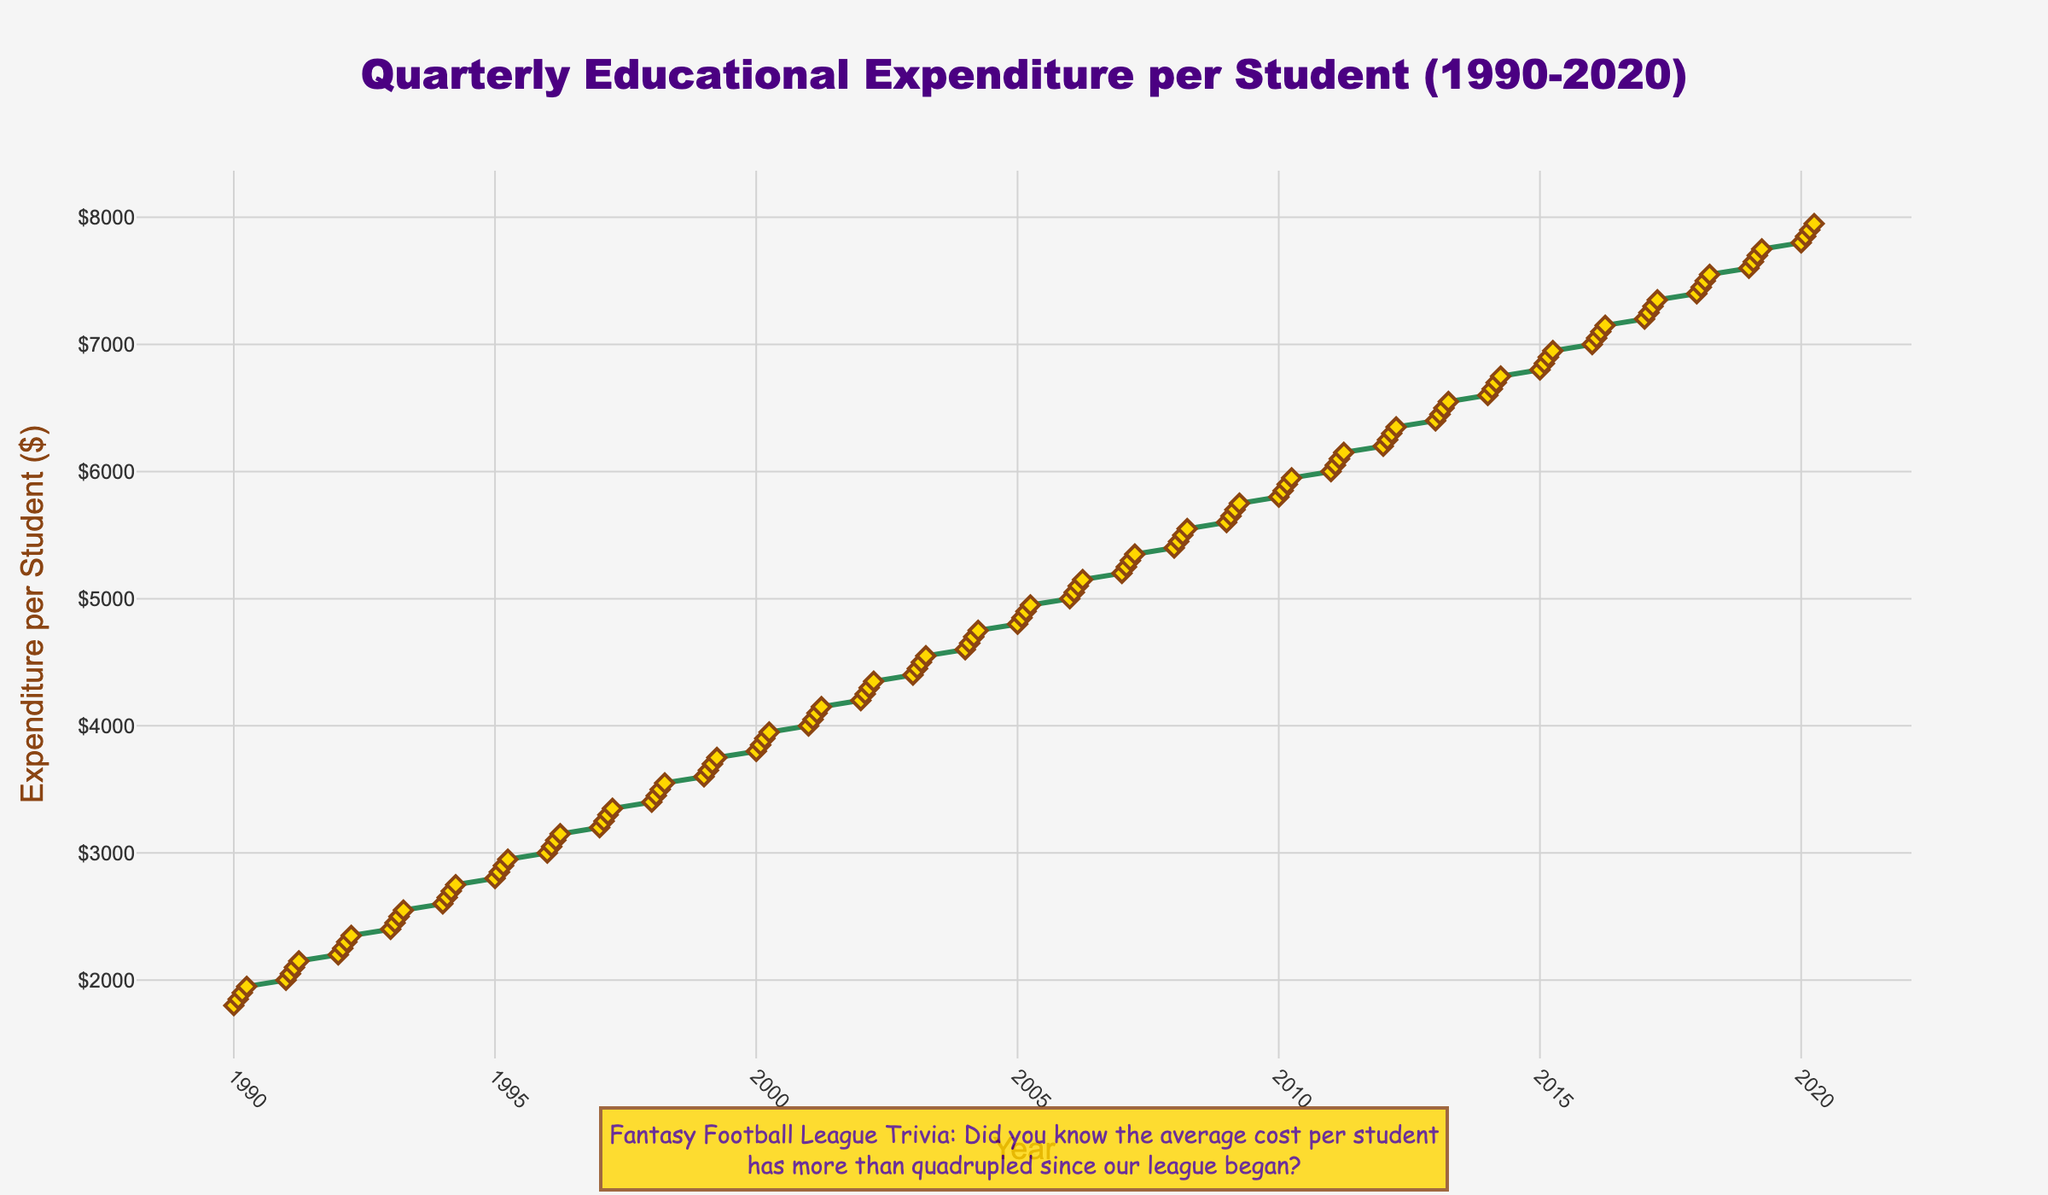What's the title of the figure? The title of the figure is the text displayed at the top of the plot, which gives an overview of what the plot is about. Look at the top center of the plot to find it.
Answer: Quarterly Educational Expenditure per Student (1990-2020) What is represented on the x-axis? The x-axis typically represents the horizontal axis on the plot and its label describes what is being measured along this axis. Look at the horizontal axis title of the figure.
Answer: Year What is represented on the y-axis? The y-axis normally shows the vertical axis on the plot and its label indicates what is being measured along this axis. Check the vertical axis title of the figure.
Answer: Expenditure per Student ($) How does the educational expenditure per student change over time from the start to end of the period? To understand this, observe the overall trend of the line from the beginning (1990) to the end (2020). Note if the line is ascending, descending, or staying constant.
Answer: Increasing By how much did the educational expenditure per student increase from 1990 Q1 to 2020 Q4? First, find the expenditure for 1990 Q1 and 2020 Q4, then subtract the former from the latter. The exact values are $1800 for 1990 Q1 and $7950 for 2020 Q4.
Answer: $6150 During which quarter and year did the expenditure first surpass $5000? Look along the y-axis to find where the expenditure first goes above $5000, then trace down vertically to correlate it with the corresponding year and quarter on the x-axis.
Answer: 2006 Q1 Compare the educational expenditure per student in Q1 of 2015 and Q1 of 2020. Which one is higher and by how much? Find the expenditure values for Q1 of 2015 and Q1 of 2020 on the plot. Subtract the 2015 value from the 2020 value to get the difference. The expenditure in Q1 of 2015 is $6800 and in Q1 of 2020 is $7800.
Answer: 2020 is higher by $1000 What is the average quarterly expenditure per student for the year 2010? To find the average, locate the expenditures for all four quarters of 2010, then sum those values and divide by 4. The values are $5800, $5850, $5900, and $5950. Sum is $23500, and average is $23500/4.
Answer: $5875 What trend can you observe during the period from 2000 to 2010? Examine the period between 2000 and 2010 on the plot and note the general direction in which the expenditure line is moving (up, down, or constant).
Answer: Upward trend What is the annotation added to the figure? An annotation is a piece of additional text typically added to emphasize or provide extra context. Look for this extra text somewhere around the plot area.
Answer: Fantasy Football League Trivia: Did you know the average cost per student has more than quadrupled since our league began? 